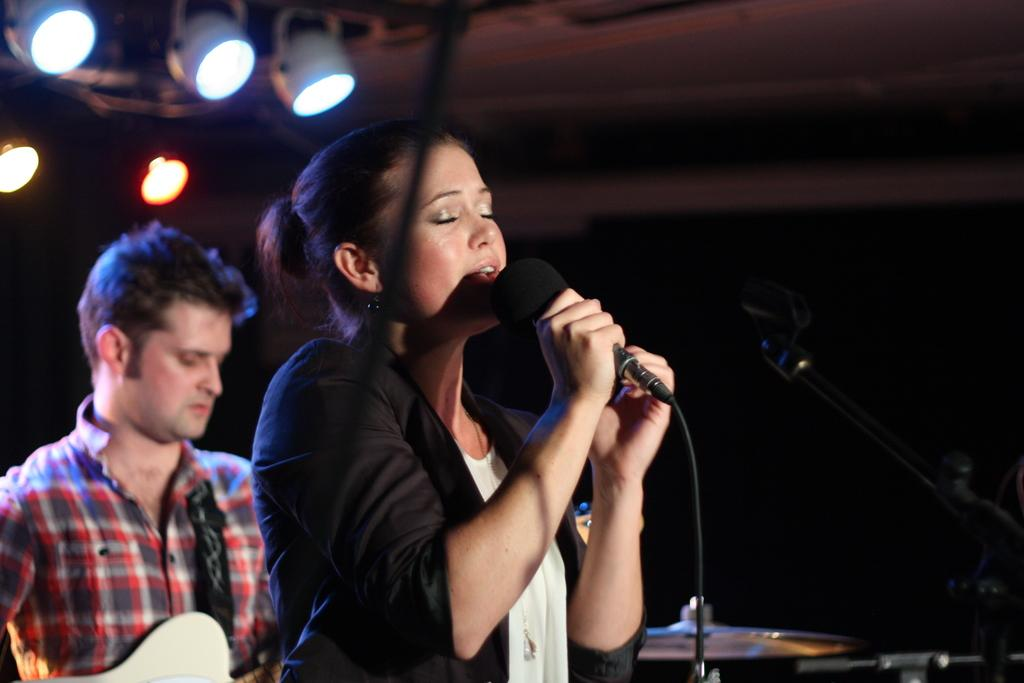What is the woman in the image doing? The woman is singing in the image. What object is the woman holding while singing? The woman is holding a microphone. What is the man in the image doing? The man is playing a guitar. What type of bird can be seen flying in the image? There is no bird present in the image. What degree does the woman have in the image? There is no mention of a degree in the image. 